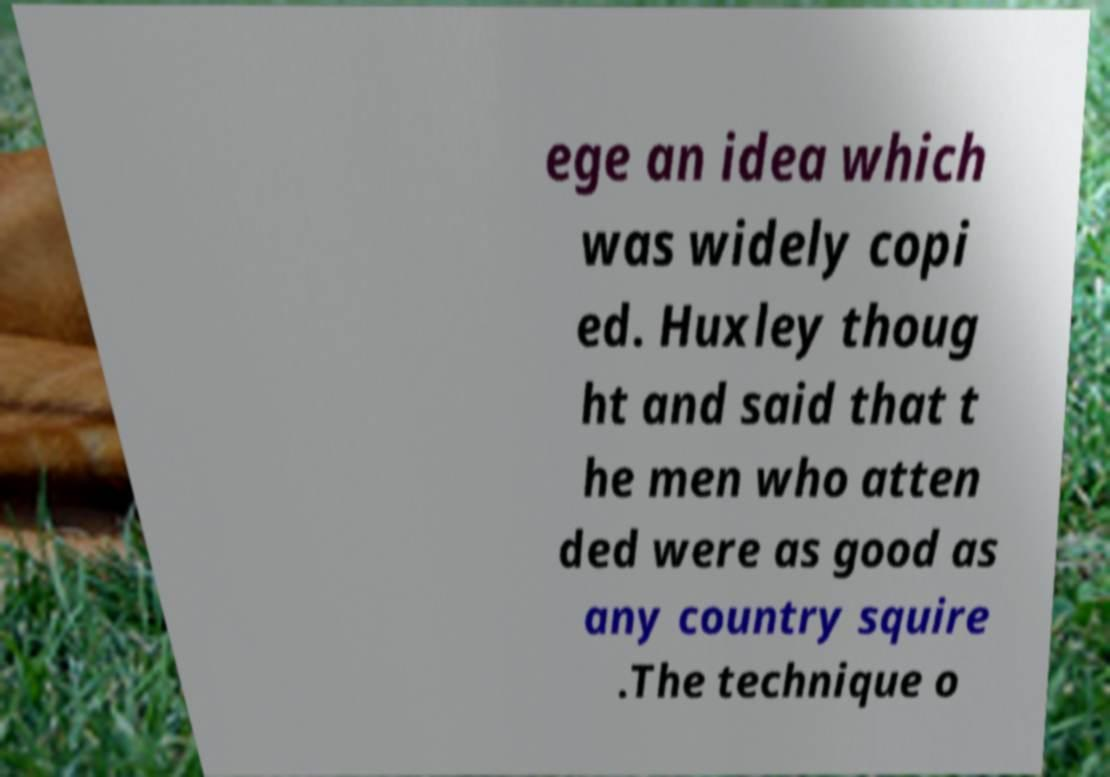What messages or text are displayed in this image? I need them in a readable, typed format. ege an idea which was widely copi ed. Huxley thoug ht and said that t he men who atten ded were as good as any country squire .The technique o 